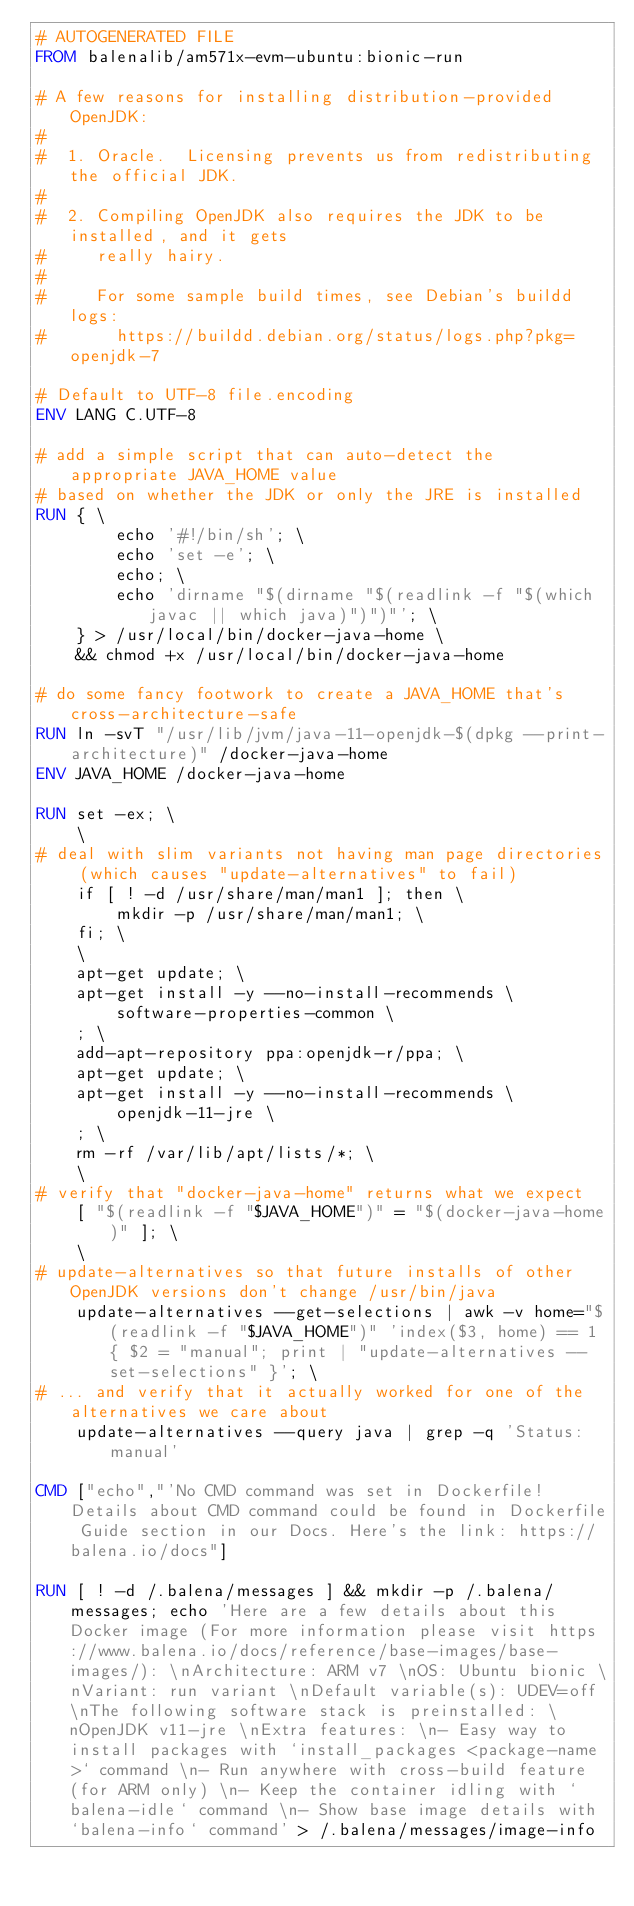<code> <loc_0><loc_0><loc_500><loc_500><_Dockerfile_># AUTOGENERATED FILE
FROM balenalib/am571x-evm-ubuntu:bionic-run

# A few reasons for installing distribution-provided OpenJDK:
#
#  1. Oracle.  Licensing prevents us from redistributing the official JDK.
#
#  2. Compiling OpenJDK also requires the JDK to be installed, and it gets
#     really hairy.
#
#     For some sample build times, see Debian's buildd logs:
#       https://buildd.debian.org/status/logs.php?pkg=openjdk-7

# Default to UTF-8 file.encoding
ENV LANG C.UTF-8

# add a simple script that can auto-detect the appropriate JAVA_HOME value
# based on whether the JDK or only the JRE is installed
RUN { \
		echo '#!/bin/sh'; \
		echo 'set -e'; \
		echo; \
		echo 'dirname "$(dirname "$(readlink -f "$(which javac || which java)")")"'; \
	} > /usr/local/bin/docker-java-home \
	&& chmod +x /usr/local/bin/docker-java-home

# do some fancy footwork to create a JAVA_HOME that's cross-architecture-safe
RUN ln -svT "/usr/lib/jvm/java-11-openjdk-$(dpkg --print-architecture)" /docker-java-home
ENV JAVA_HOME /docker-java-home

RUN set -ex; \
	\
# deal with slim variants not having man page directories (which causes "update-alternatives" to fail)
	if [ ! -d /usr/share/man/man1 ]; then \
		mkdir -p /usr/share/man/man1; \
	fi; \
	\
	apt-get update; \
	apt-get install -y --no-install-recommends \
		software-properties-common \
	; \
	add-apt-repository ppa:openjdk-r/ppa; \
	apt-get update; \
	apt-get install -y --no-install-recommends \
		openjdk-11-jre \
	; \
	rm -rf /var/lib/apt/lists/*; \
	\
# verify that "docker-java-home" returns what we expect
	[ "$(readlink -f "$JAVA_HOME")" = "$(docker-java-home)" ]; \
	\
# update-alternatives so that future installs of other OpenJDK versions don't change /usr/bin/java
	update-alternatives --get-selections | awk -v home="$(readlink -f "$JAVA_HOME")" 'index($3, home) == 1 { $2 = "manual"; print | "update-alternatives --set-selections" }'; \
# ... and verify that it actually worked for one of the alternatives we care about
	update-alternatives --query java | grep -q 'Status: manual'

CMD ["echo","'No CMD command was set in Dockerfile! Details about CMD command could be found in Dockerfile Guide section in our Docs. Here's the link: https://balena.io/docs"]

RUN [ ! -d /.balena/messages ] && mkdir -p /.balena/messages; echo 'Here are a few details about this Docker image (For more information please visit https://www.balena.io/docs/reference/base-images/base-images/): \nArchitecture: ARM v7 \nOS: Ubuntu bionic \nVariant: run variant \nDefault variable(s): UDEV=off \nThe following software stack is preinstalled: \nOpenJDK v11-jre \nExtra features: \n- Easy way to install packages with `install_packages <package-name>` command \n- Run anywhere with cross-build feature  (for ARM only) \n- Keep the container idling with `balena-idle` command \n- Show base image details with `balena-info` command' > /.balena/messages/image-info</code> 